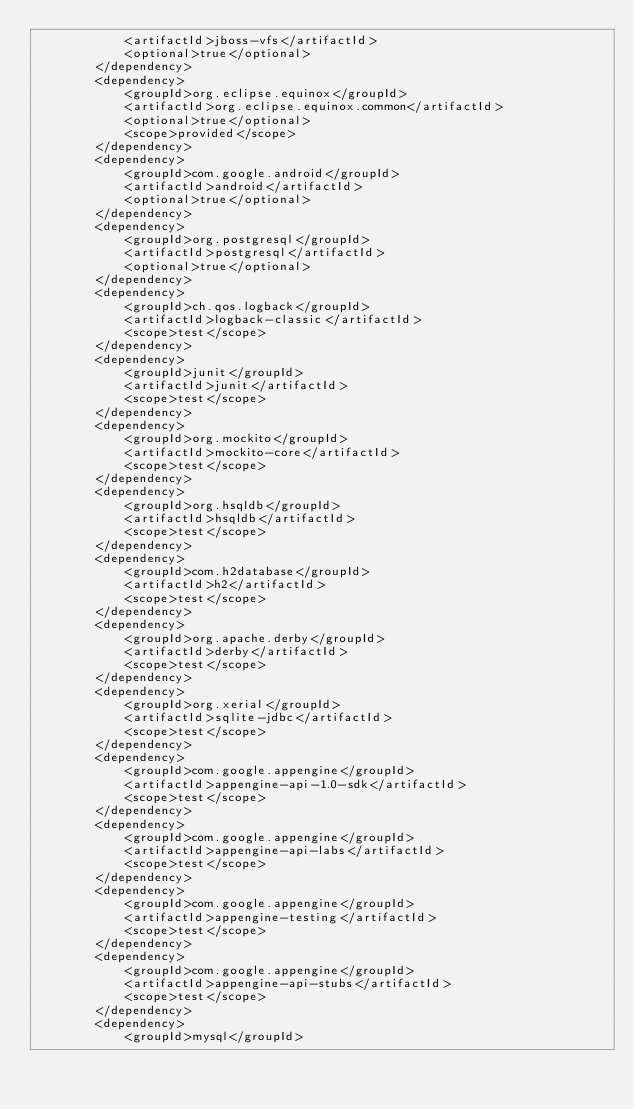Convert code to text. <code><loc_0><loc_0><loc_500><loc_500><_XML_>            <artifactId>jboss-vfs</artifactId>
            <optional>true</optional>
        </dependency>
        <dependency>
            <groupId>org.eclipse.equinox</groupId>
            <artifactId>org.eclipse.equinox.common</artifactId>
            <optional>true</optional>
            <scope>provided</scope>
        </dependency>
        <dependency>
            <groupId>com.google.android</groupId>
            <artifactId>android</artifactId>
            <optional>true</optional>
        </dependency>
        <dependency>
            <groupId>org.postgresql</groupId>
            <artifactId>postgresql</artifactId>
            <optional>true</optional>
        </dependency>
        <dependency>
            <groupId>ch.qos.logback</groupId>
            <artifactId>logback-classic</artifactId>
            <scope>test</scope>
        </dependency>
        <dependency>
            <groupId>junit</groupId>
            <artifactId>junit</artifactId>
            <scope>test</scope>
        </dependency>
        <dependency>
            <groupId>org.mockito</groupId>
            <artifactId>mockito-core</artifactId>
            <scope>test</scope>
        </dependency>
        <dependency>
            <groupId>org.hsqldb</groupId>
            <artifactId>hsqldb</artifactId>
            <scope>test</scope>
        </dependency>
        <dependency>
            <groupId>com.h2database</groupId>
            <artifactId>h2</artifactId>
            <scope>test</scope>
        </dependency>
        <dependency>
            <groupId>org.apache.derby</groupId>
            <artifactId>derby</artifactId>
            <scope>test</scope>
        </dependency>
        <dependency>
            <groupId>org.xerial</groupId>
            <artifactId>sqlite-jdbc</artifactId>
            <scope>test</scope>
        </dependency>
        <dependency>
            <groupId>com.google.appengine</groupId>
            <artifactId>appengine-api-1.0-sdk</artifactId>
            <scope>test</scope>
        </dependency>
        <dependency>
            <groupId>com.google.appengine</groupId>
            <artifactId>appengine-api-labs</artifactId>
            <scope>test</scope>
        </dependency>
        <dependency>
            <groupId>com.google.appengine</groupId>
            <artifactId>appengine-testing</artifactId>
            <scope>test</scope>
        </dependency>
        <dependency>
            <groupId>com.google.appengine</groupId>
            <artifactId>appengine-api-stubs</artifactId>
            <scope>test</scope>
        </dependency>
        <dependency>
            <groupId>mysql</groupId></code> 